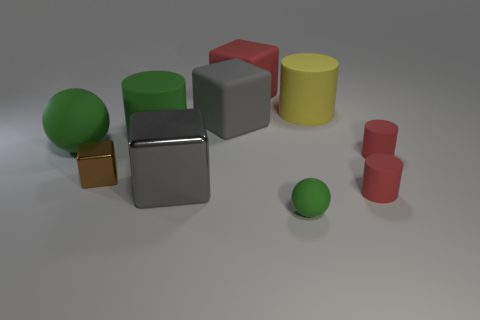The thing that is the same color as the big metal cube is what size?
Offer a very short reply. Large. How big is the brown block left of the green object that is in front of the big green matte ball?
Offer a very short reply. Small. There is a red rubber thing to the left of the big yellow rubber cylinder; is it the same shape as the large gray thing that is on the right side of the big gray metal block?
Your answer should be very brief. Yes. There is a green rubber thing that is to the left of the large cylinder that is left of the red matte block; what shape is it?
Offer a terse response. Sphere. There is a rubber cylinder that is both behind the big ball and to the right of the tiny sphere; what size is it?
Offer a very short reply. Large. Do the tiny green object and the big thing that is to the left of the small brown metal object have the same shape?
Ensure brevity in your answer.  Yes. There is another metal thing that is the same shape as the small brown shiny thing; what size is it?
Offer a very short reply. Large. There is a tiny ball; does it have the same color as the matte ball that is behind the tiny matte ball?
Your answer should be compact. Yes. What number of other objects are there of the same size as the gray matte object?
Keep it short and to the point. 5. What shape is the large thing that is to the right of the red object that is on the left side of the green thing on the right side of the gray shiny thing?
Provide a short and direct response. Cylinder. 